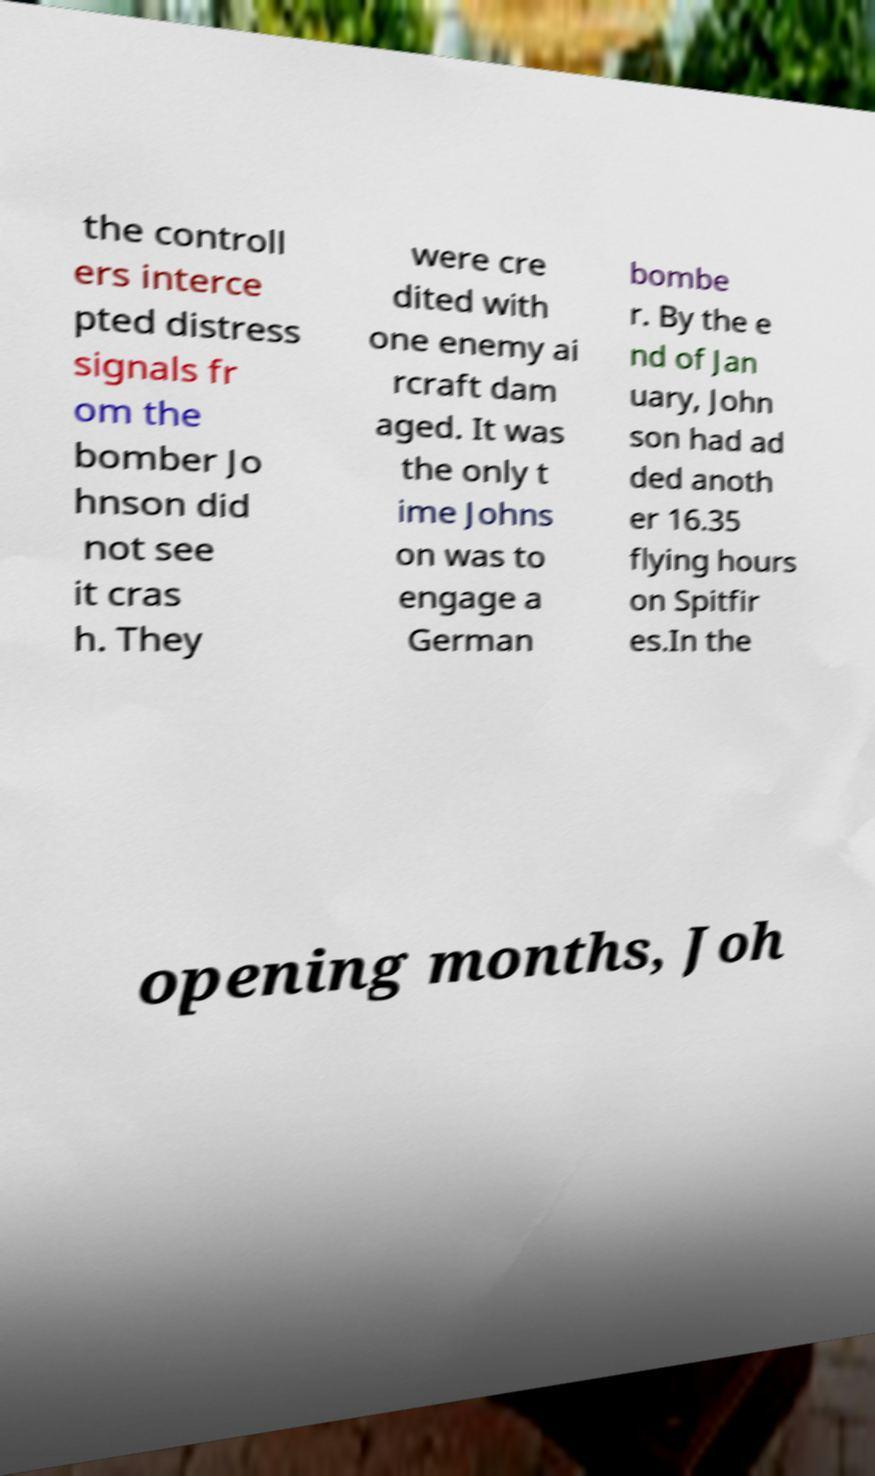Could you assist in decoding the text presented in this image and type it out clearly? the controll ers interce pted distress signals fr om the bomber Jo hnson did not see it cras h. They were cre dited with one enemy ai rcraft dam aged. It was the only t ime Johns on was to engage a German bombe r. By the e nd of Jan uary, John son had ad ded anoth er 16.35 flying hours on Spitfir es.In the opening months, Joh 